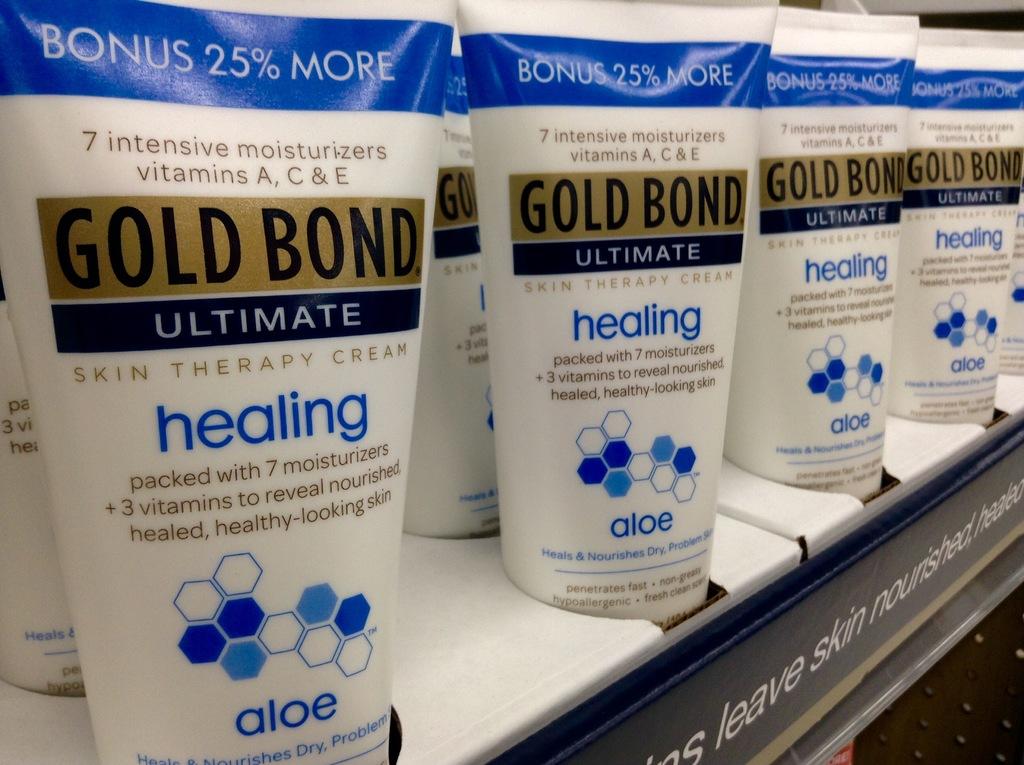What is the maker of the cream?
Give a very brief answer. Gold bond. 